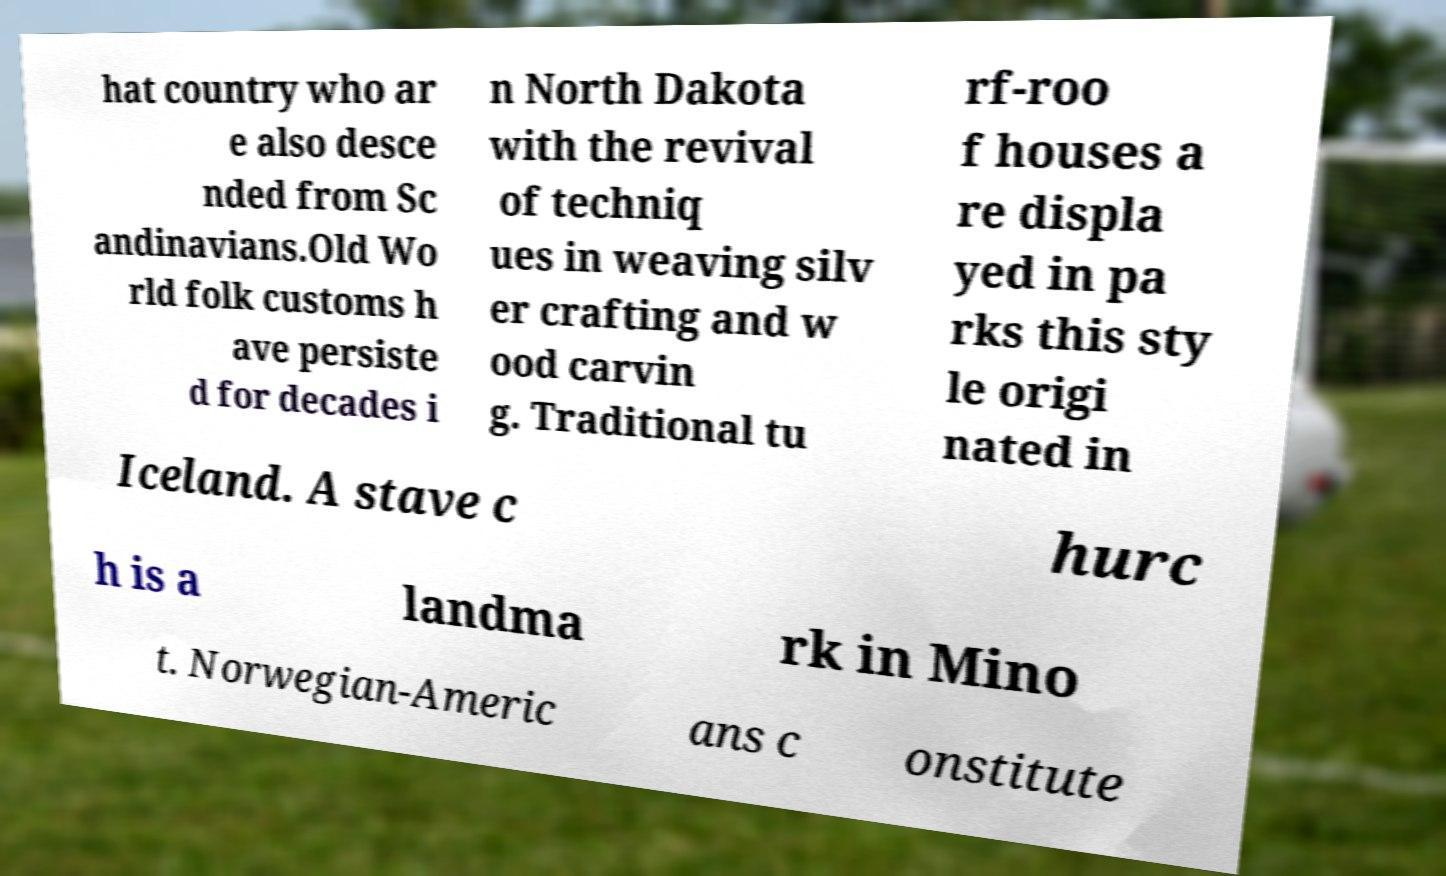Please identify and transcribe the text found in this image. hat country who ar e also desce nded from Sc andinavians.Old Wo rld folk customs h ave persiste d for decades i n North Dakota with the revival of techniq ues in weaving silv er crafting and w ood carvin g. Traditional tu rf-roo f houses a re displa yed in pa rks this sty le origi nated in Iceland. A stave c hurc h is a landma rk in Mino t. Norwegian-Americ ans c onstitute 